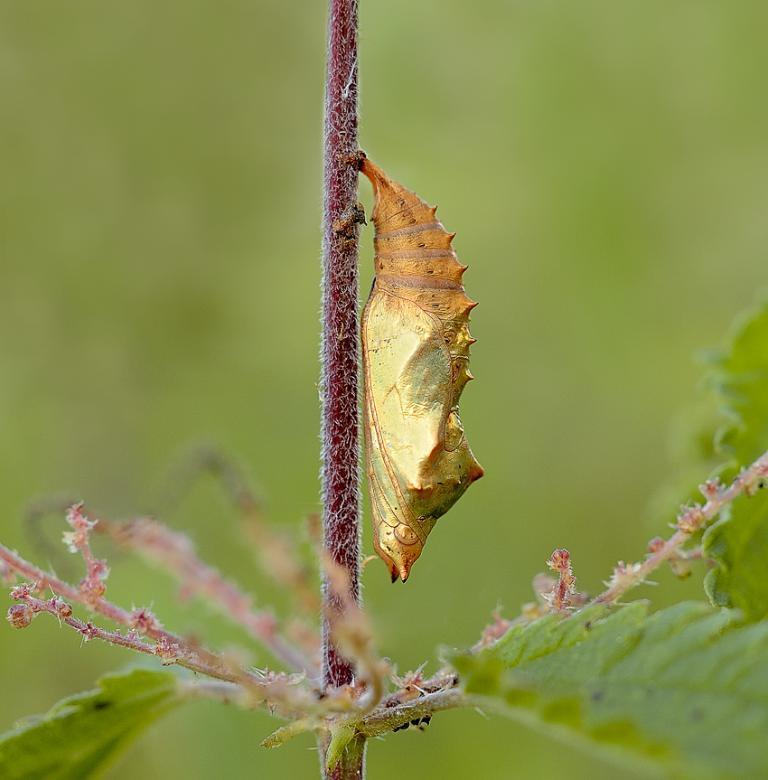Can you describe this image briefly? In this image we can see an insect on the stem of a plant and we can see leaves. In the background the image is blur. 